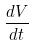Convert formula to latex. <formula><loc_0><loc_0><loc_500><loc_500>\frac { d V } { d t }</formula> 